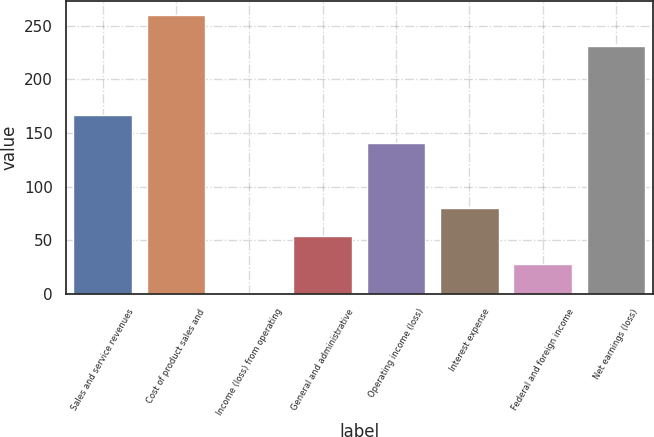Convert chart. <chart><loc_0><loc_0><loc_500><loc_500><bar_chart><fcel>Sales and service revenues<fcel>Cost of product sales and<fcel>Income (loss) from operating<fcel>General and administrative<fcel>Operating income (loss)<fcel>Interest expense<fcel>Federal and foreign income<fcel>Net earnings (loss)<nl><fcel>166.9<fcel>260<fcel>1<fcel>53.9<fcel>141<fcel>79.8<fcel>28<fcel>231<nl></chart> 